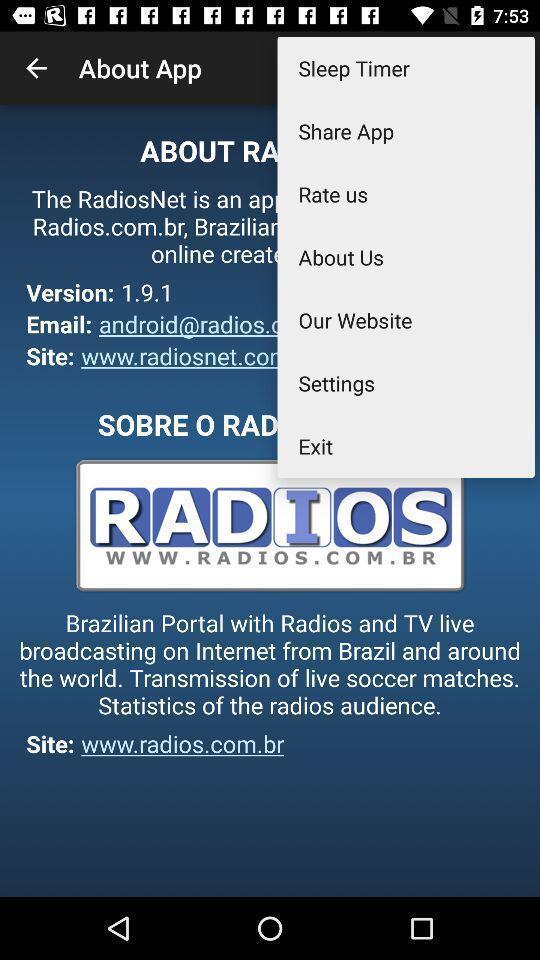Give me a narrative description of this picture. Page shows different options. 